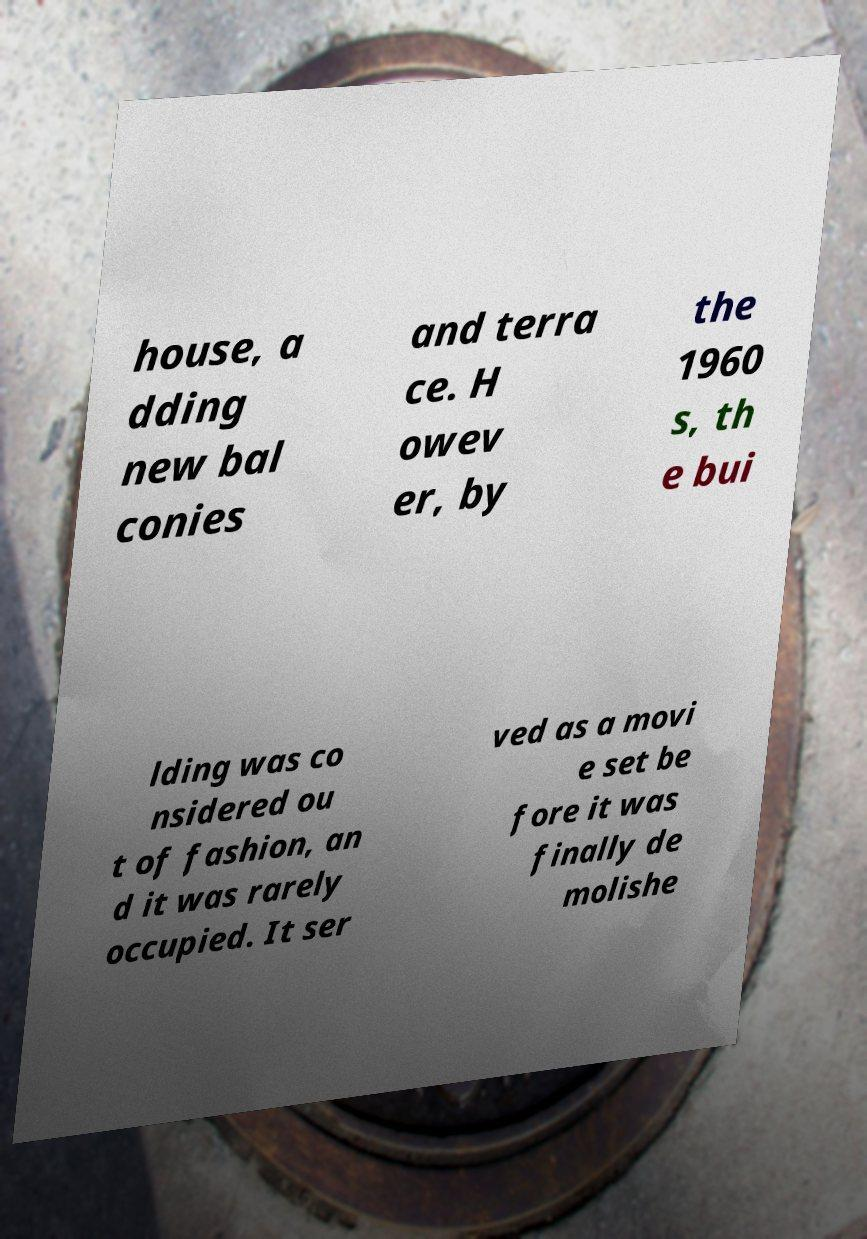Please identify and transcribe the text found in this image. house, a dding new bal conies and terra ce. H owev er, by the 1960 s, th e bui lding was co nsidered ou t of fashion, an d it was rarely occupied. It ser ved as a movi e set be fore it was finally de molishe 